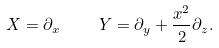Convert formula to latex. <formula><loc_0><loc_0><loc_500><loc_500>X = \partial _ { x } \quad \ Y = \partial _ { y } + \frac { x ^ { 2 } } { 2 } \partial _ { z } .</formula> 